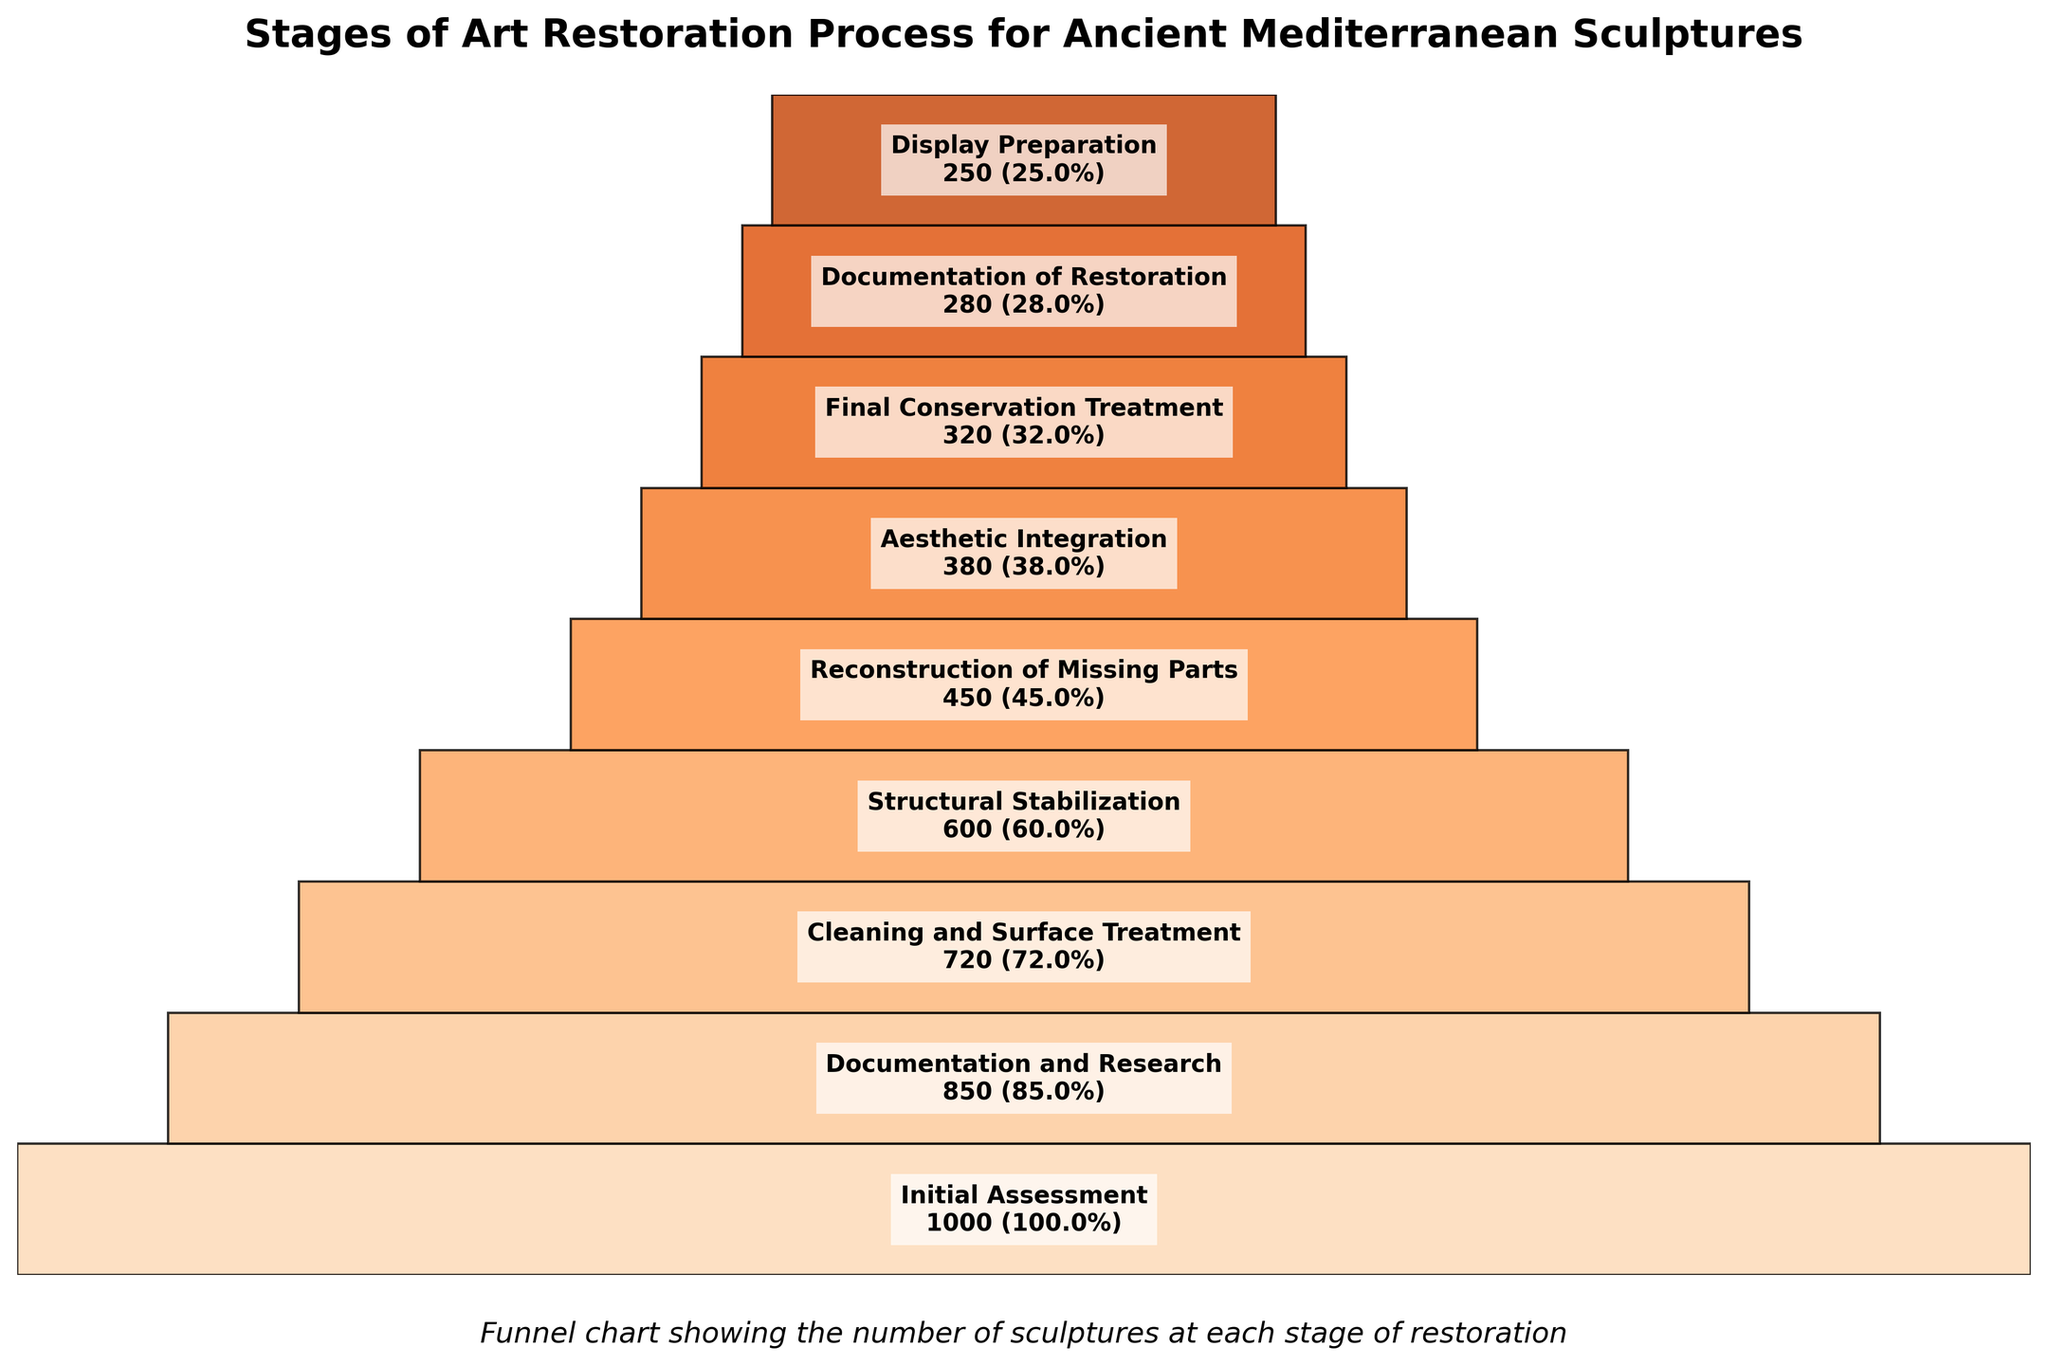What is the title of the funnel chart? The title is located at the top of the chart and is usually written in a larger and bold font for emphasis.
Answer: Stages of Art Restoration Process for Ancient Mediterranean Sculptures Which stage has the highest number of sculptures? The first section at the top of the funnel chart represents the stage with the highest number of sculptures.
Answer: Initial Assessment By how many sculptures does the "Documentation and Research" stage reduce in comparison to the "Initial Assessment" stage? Subtract the number of sculptures in the "Documentation and Research" stage (850) from the "Initial Assessment" stage (1000). 1000 - 850 = 150.
Answer: 150 Which stage has the lowest number of sculptures? The last section at the bottom of the funnel chart represents the stage with the lowest number of sculptures.
Answer: Display Preparation What percentage of the sculptures reach the "Final Conservation Treatment" stage? Look at the percentage value written within the "Final Conservation Treatment" stage section.
Answer: 32.0% By what percentage do the sculptures decrease from "Cleaning and Surface Treatment" to "Structural Stabilization"? Subtract the percentage for "Structural Stabilization" (60%) from the percentage for "Cleaning and Surface Treatment" (72%). 72% - 60% = 12%.
Answer: 12% What stage follows immediately after "Reconstruction of Missing Parts"? Identify the next section just below the "Reconstruction of Missing Parts" stage within the funnel chart.
Answer: Aesthetic Integration How does the number of sculptures in "Aesthetic Integration" compare to those in "Structural Stabilization"? Subtract the number of sculptures in "Aesthetic Integration" (380) from the "Structural Stabilization" stage (600). 600 - 380 = 220 sculptures.
Answer: 220 fewer Which stages have fewer than 300 sculptures? Identify the stages within the funnel where the number of sculptures is listed as less than 300.
Answer: Final Conservation Treatment, Documentation of Restoration, Display Preparation What is the total number of sculptures across the last three stages in the funnel? Add up the number of sculptures in the last three stages: "Documentation of Restoration" (280), "Display Preparation" (250), and "Final Conservation Treatment" (320). 280 + 250 + 320 = 850.
Answer: 850 